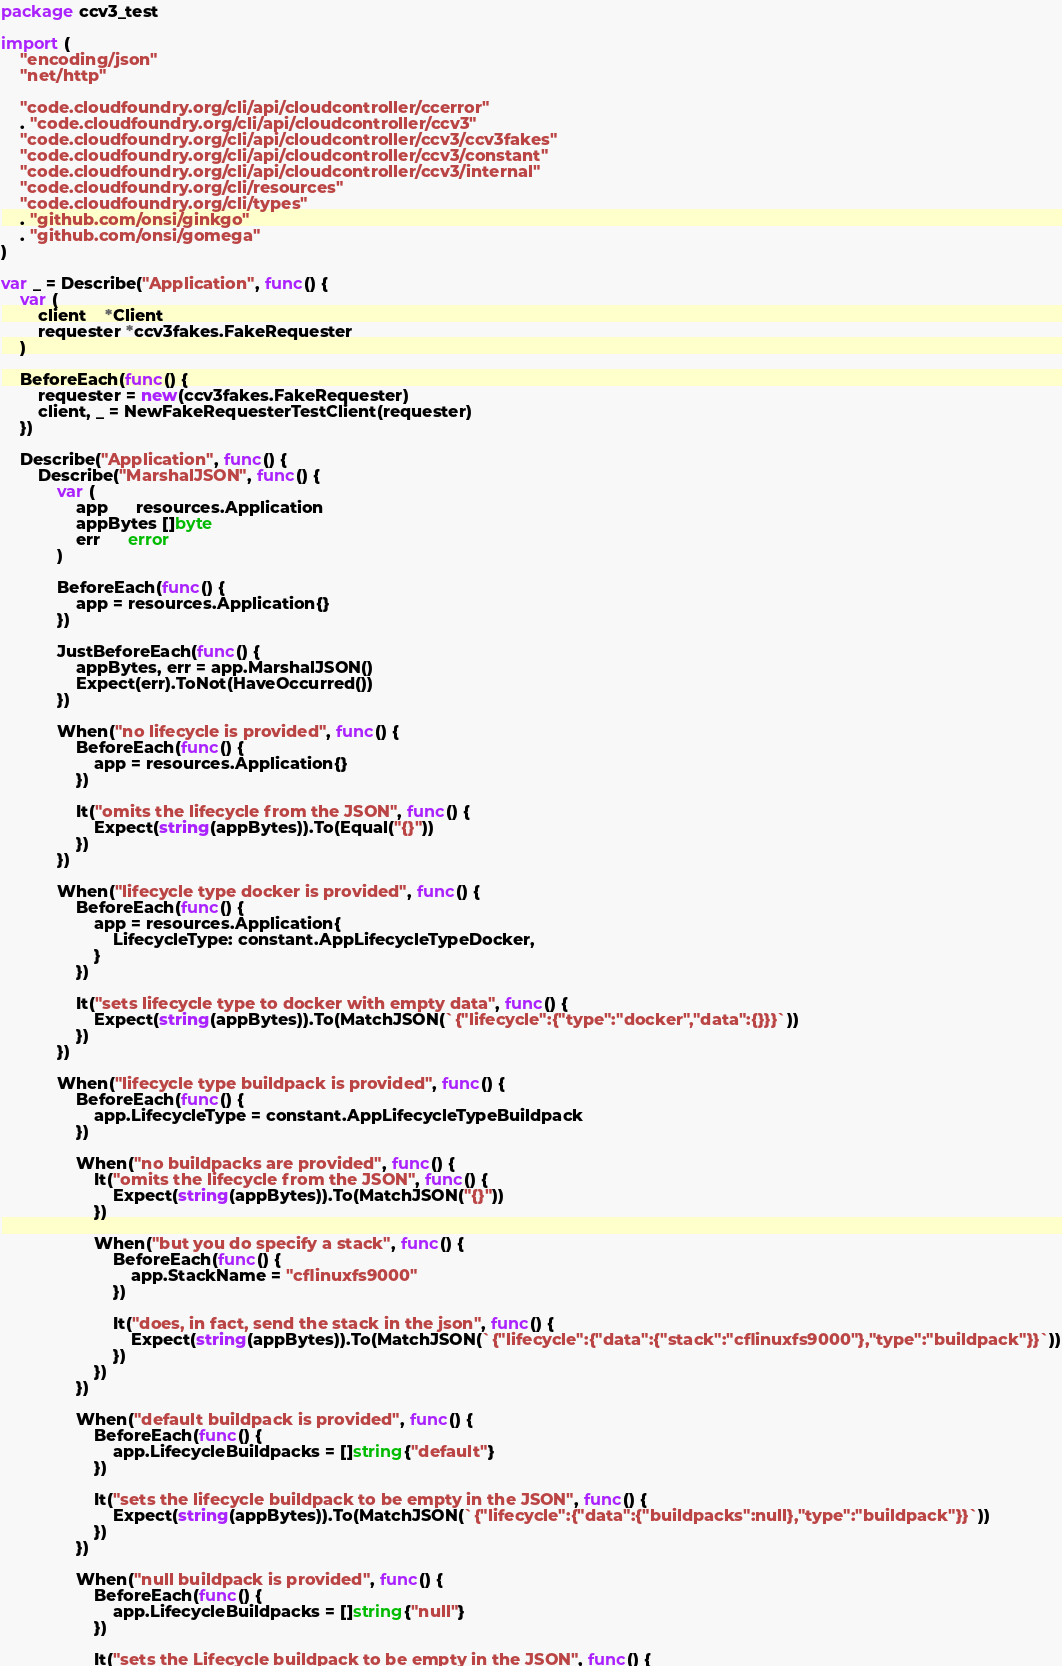Convert code to text. <code><loc_0><loc_0><loc_500><loc_500><_Go_>package ccv3_test

import (
	"encoding/json"
	"net/http"

	"code.cloudfoundry.org/cli/api/cloudcontroller/ccerror"
	. "code.cloudfoundry.org/cli/api/cloudcontroller/ccv3"
	"code.cloudfoundry.org/cli/api/cloudcontroller/ccv3/ccv3fakes"
	"code.cloudfoundry.org/cli/api/cloudcontroller/ccv3/constant"
	"code.cloudfoundry.org/cli/api/cloudcontroller/ccv3/internal"
	"code.cloudfoundry.org/cli/resources"
	"code.cloudfoundry.org/cli/types"
	. "github.com/onsi/ginkgo"
	. "github.com/onsi/gomega"
)

var _ = Describe("Application", func() {
	var (
		client    *Client
		requester *ccv3fakes.FakeRequester
	)

	BeforeEach(func() {
		requester = new(ccv3fakes.FakeRequester)
		client, _ = NewFakeRequesterTestClient(requester)
	})

	Describe("Application", func() {
		Describe("MarshalJSON", func() {
			var (
				app      resources.Application
				appBytes []byte
				err      error
			)

			BeforeEach(func() {
				app = resources.Application{}
			})

			JustBeforeEach(func() {
				appBytes, err = app.MarshalJSON()
				Expect(err).ToNot(HaveOccurred())
			})

			When("no lifecycle is provided", func() {
				BeforeEach(func() {
					app = resources.Application{}
				})

				It("omits the lifecycle from the JSON", func() {
					Expect(string(appBytes)).To(Equal("{}"))
				})
			})

			When("lifecycle type docker is provided", func() {
				BeforeEach(func() {
					app = resources.Application{
						LifecycleType: constant.AppLifecycleTypeDocker,
					}
				})

				It("sets lifecycle type to docker with empty data", func() {
					Expect(string(appBytes)).To(MatchJSON(`{"lifecycle":{"type":"docker","data":{}}}`))
				})
			})

			When("lifecycle type buildpack is provided", func() {
				BeforeEach(func() {
					app.LifecycleType = constant.AppLifecycleTypeBuildpack
				})

				When("no buildpacks are provided", func() {
					It("omits the lifecycle from the JSON", func() {
						Expect(string(appBytes)).To(MatchJSON("{}"))
					})

					When("but you do specify a stack", func() {
						BeforeEach(func() {
							app.StackName = "cflinuxfs9000"
						})

						It("does, in fact, send the stack in the json", func() {
							Expect(string(appBytes)).To(MatchJSON(`{"lifecycle":{"data":{"stack":"cflinuxfs9000"},"type":"buildpack"}}`))
						})
					})
				})

				When("default buildpack is provided", func() {
					BeforeEach(func() {
						app.LifecycleBuildpacks = []string{"default"}
					})

					It("sets the lifecycle buildpack to be empty in the JSON", func() {
						Expect(string(appBytes)).To(MatchJSON(`{"lifecycle":{"data":{"buildpacks":null},"type":"buildpack"}}`))
					})
				})

				When("null buildpack is provided", func() {
					BeforeEach(func() {
						app.LifecycleBuildpacks = []string{"null"}
					})

					It("sets the Lifecycle buildpack to be empty in the JSON", func() {</code> 